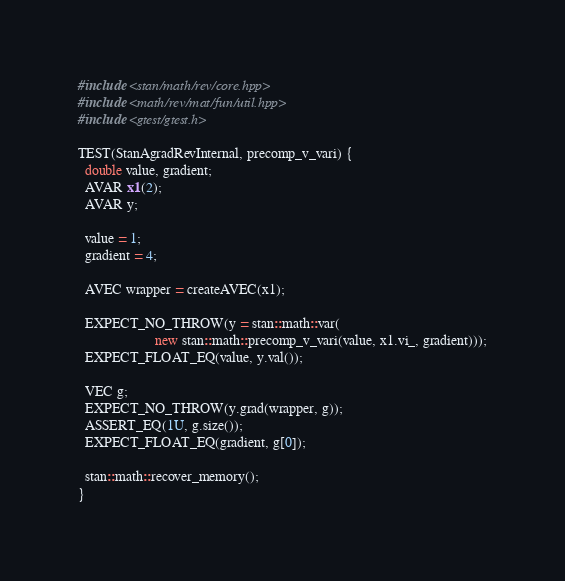Convert code to text. <code><loc_0><loc_0><loc_500><loc_500><_C++_>#include <stan/math/rev/core.hpp>
#include <math/rev/mat/fun/util.hpp>
#include <gtest/gtest.h>

TEST(StanAgradRevInternal, precomp_v_vari) {
  double value, gradient;
  AVAR x1(2);
  AVAR y;

  value = 1;
  gradient = 4;

  AVEC wrapper = createAVEC(x1);

  EXPECT_NO_THROW(y = stan::math::var(
                      new stan::math::precomp_v_vari(value, x1.vi_, gradient)));
  EXPECT_FLOAT_EQ(value, y.val());

  VEC g;
  EXPECT_NO_THROW(y.grad(wrapper, g));
  ASSERT_EQ(1U, g.size());
  EXPECT_FLOAT_EQ(gradient, g[0]);

  stan::math::recover_memory();
}
</code> 